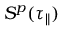<formula> <loc_0><loc_0><loc_500><loc_500>S ^ { p } ( \tau _ { \| } )</formula> 